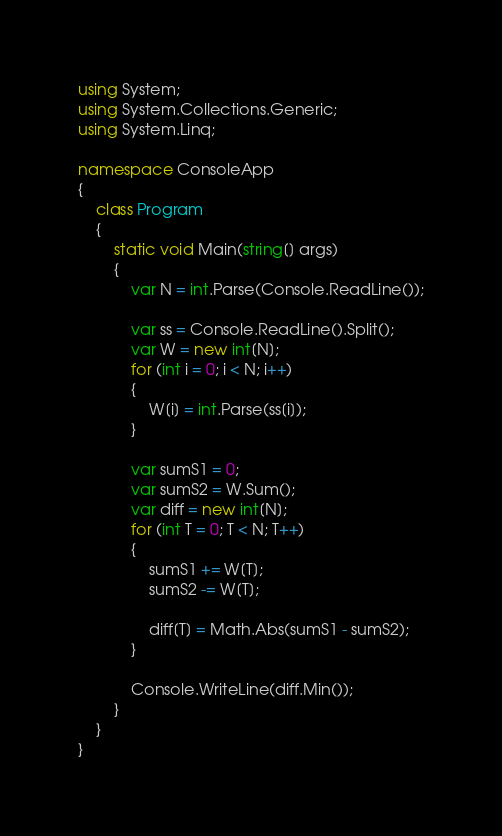<code> <loc_0><loc_0><loc_500><loc_500><_C#_>using System;
using System.Collections.Generic;
using System.Linq;

namespace ConsoleApp
{
    class Program
    {
        static void Main(string[] args)
        {
            var N = int.Parse(Console.ReadLine());

            var ss = Console.ReadLine().Split();
            var W = new int[N];
            for (int i = 0; i < N; i++)
            {
                W[i] = int.Parse(ss[i]);
            }

            var sumS1 = 0;
            var sumS2 = W.Sum();
            var diff = new int[N];
            for (int T = 0; T < N; T++)
            {
                sumS1 += W[T];
                sumS2 -= W[T];

                diff[T] = Math.Abs(sumS1 - sumS2);
            }

            Console.WriteLine(diff.Min());
        }
    }
}</code> 